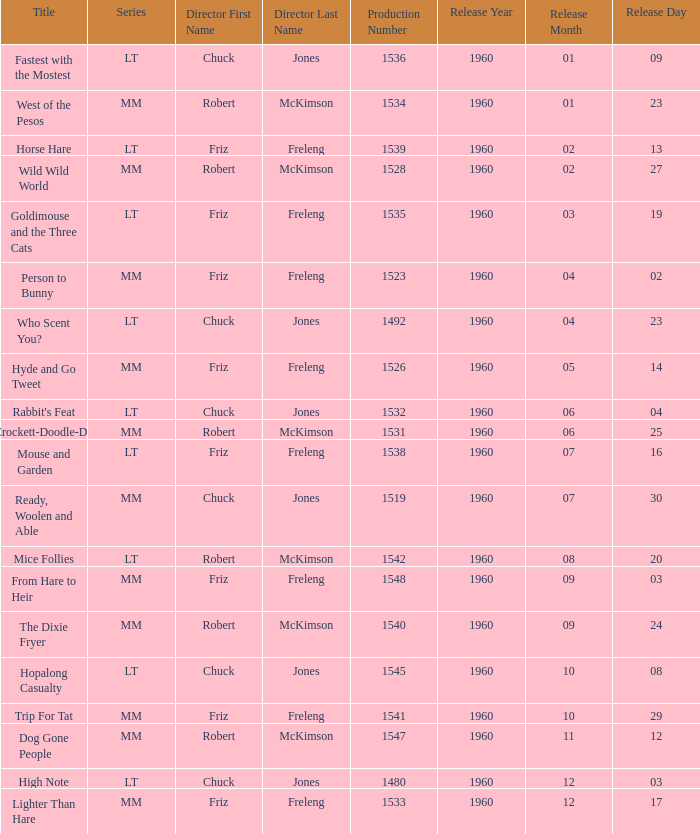What is the production number for the episode directed by Robert McKimson named Mice Follies? 1.0. 